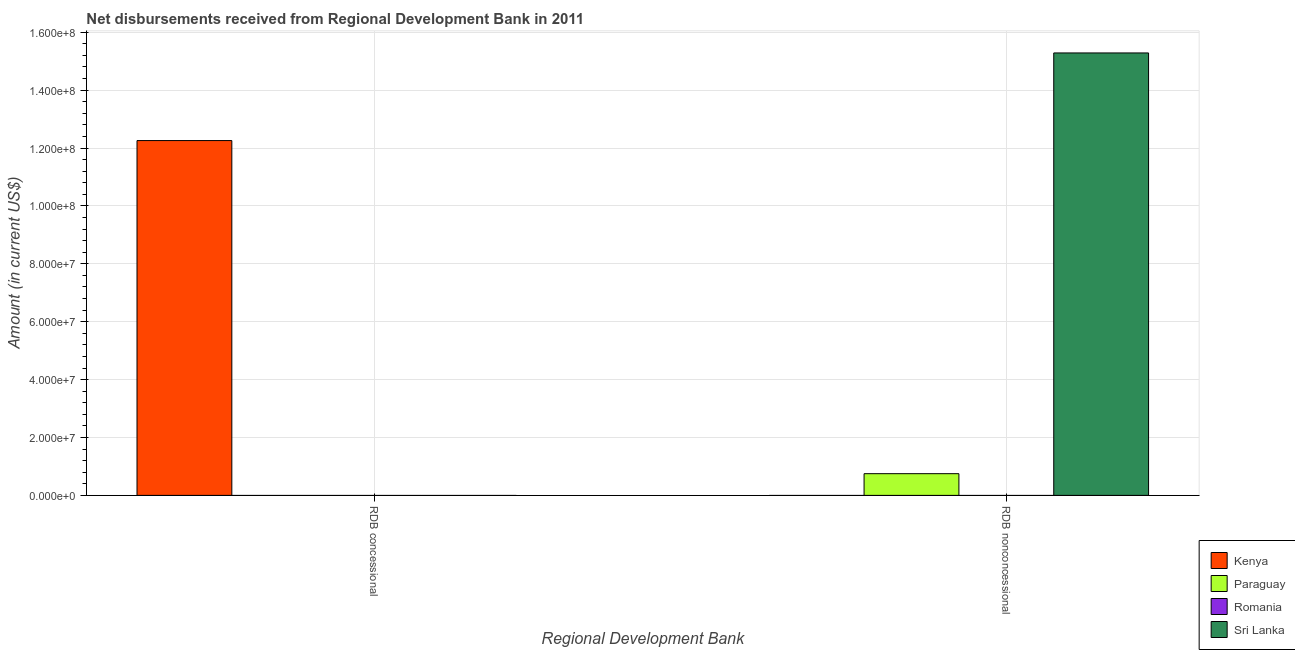Are the number of bars on each tick of the X-axis equal?
Your answer should be compact. No. How many bars are there on the 1st tick from the right?
Offer a very short reply. 2. What is the label of the 1st group of bars from the left?
Your answer should be compact. RDB concessional. What is the net non concessional disbursements from rdb in Paraguay?
Keep it short and to the point. 7.50e+06. Across all countries, what is the maximum net concessional disbursements from rdb?
Your answer should be compact. 1.23e+08. In which country was the net non concessional disbursements from rdb maximum?
Give a very brief answer. Sri Lanka. What is the total net concessional disbursements from rdb in the graph?
Your response must be concise. 1.23e+08. What is the difference between the net concessional disbursements from rdb in Sri Lanka and the net non concessional disbursements from rdb in Kenya?
Your answer should be very brief. 0. What is the average net concessional disbursements from rdb per country?
Give a very brief answer. 3.06e+07. In how many countries, is the net concessional disbursements from rdb greater than 84000000 US$?
Provide a succinct answer. 1. What is the ratio of the net non concessional disbursements from rdb in Paraguay to that in Sri Lanka?
Make the answer very short. 0.05. In how many countries, is the net concessional disbursements from rdb greater than the average net concessional disbursements from rdb taken over all countries?
Offer a terse response. 1. What is the difference between two consecutive major ticks on the Y-axis?
Ensure brevity in your answer.  2.00e+07. Are the values on the major ticks of Y-axis written in scientific E-notation?
Make the answer very short. Yes. Does the graph contain any zero values?
Provide a short and direct response. Yes. How many legend labels are there?
Offer a very short reply. 4. How are the legend labels stacked?
Your answer should be very brief. Vertical. What is the title of the graph?
Provide a short and direct response. Net disbursements received from Regional Development Bank in 2011. What is the label or title of the X-axis?
Offer a terse response. Regional Development Bank. What is the label or title of the Y-axis?
Your answer should be compact. Amount (in current US$). What is the Amount (in current US$) in Kenya in RDB concessional?
Give a very brief answer. 1.23e+08. What is the Amount (in current US$) of Romania in RDB concessional?
Offer a very short reply. 0. What is the Amount (in current US$) in Kenya in RDB nonconcessional?
Ensure brevity in your answer.  0. What is the Amount (in current US$) of Paraguay in RDB nonconcessional?
Your answer should be compact. 7.50e+06. What is the Amount (in current US$) in Romania in RDB nonconcessional?
Your response must be concise. 0. What is the Amount (in current US$) in Sri Lanka in RDB nonconcessional?
Provide a short and direct response. 1.53e+08. Across all Regional Development Bank, what is the maximum Amount (in current US$) in Kenya?
Your response must be concise. 1.23e+08. Across all Regional Development Bank, what is the maximum Amount (in current US$) in Paraguay?
Make the answer very short. 7.50e+06. Across all Regional Development Bank, what is the maximum Amount (in current US$) of Sri Lanka?
Keep it short and to the point. 1.53e+08. Across all Regional Development Bank, what is the minimum Amount (in current US$) of Sri Lanka?
Give a very brief answer. 0. What is the total Amount (in current US$) of Kenya in the graph?
Offer a terse response. 1.23e+08. What is the total Amount (in current US$) of Paraguay in the graph?
Provide a short and direct response. 7.50e+06. What is the total Amount (in current US$) in Sri Lanka in the graph?
Offer a terse response. 1.53e+08. What is the difference between the Amount (in current US$) in Kenya in RDB concessional and the Amount (in current US$) in Paraguay in RDB nonconcessional?
Provide a short and direct response. 1.15e+08. What is the difference between the Amount (in current US$) of Kenya in RDB concessional and the Amount (in current US$) of Sri Lanka in RDB nonconcessional?
Offer a terse response. -3.03e+07. What is the average Amount (in current US$) of Kenya per Regional Development Bank?
Your answer should be very brief. 6.13e+07. What is the average Amount (in current US$) in Paraguay per Regional Development Bank?
Make the answer very short. 3.75e+06. What is the average Amount (in current US$) in Romania per Regional Development Bank?
Provide a short and direct response. 0. What is the average Amount (in current US$) in Sri Lanka per Regional Development Bank?
Provide a short and direct response. 7.64e+07. What is the difference between the Amount (in current US$) of Paraguay and Amount (in current US$) of Sri Lanka in RDB nonconcessional?
Your answer should be very brief. -1.45e+08. What is the difference between the highest and the lowest Amount (in current US$) of Kenya?
Your response must be concise. 1.23e+08. What is the difference between the highest and the lowest Amount (in current US$) in Paraguay?
Your response must be concise. 7.50e+06. What is the difference between the highest and the lowest Amount (in current US$) in Sri Lanka?
Offer a very short reply. 1.53e+08. 